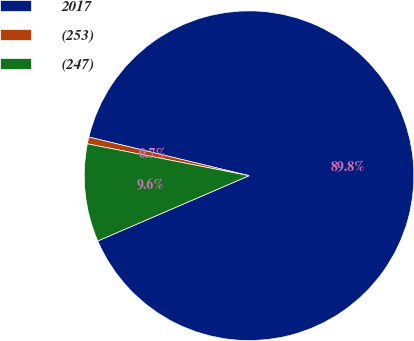Convert chart to OTSL. <chart><loc_0><loc_0><loc_500><loc_500><pie_chart><fcel>2017<fcel>(253)<fcel>(247)<nl><fcel>89.76%<fcel>0.67%<fcel>9.58%<nl></chart> 